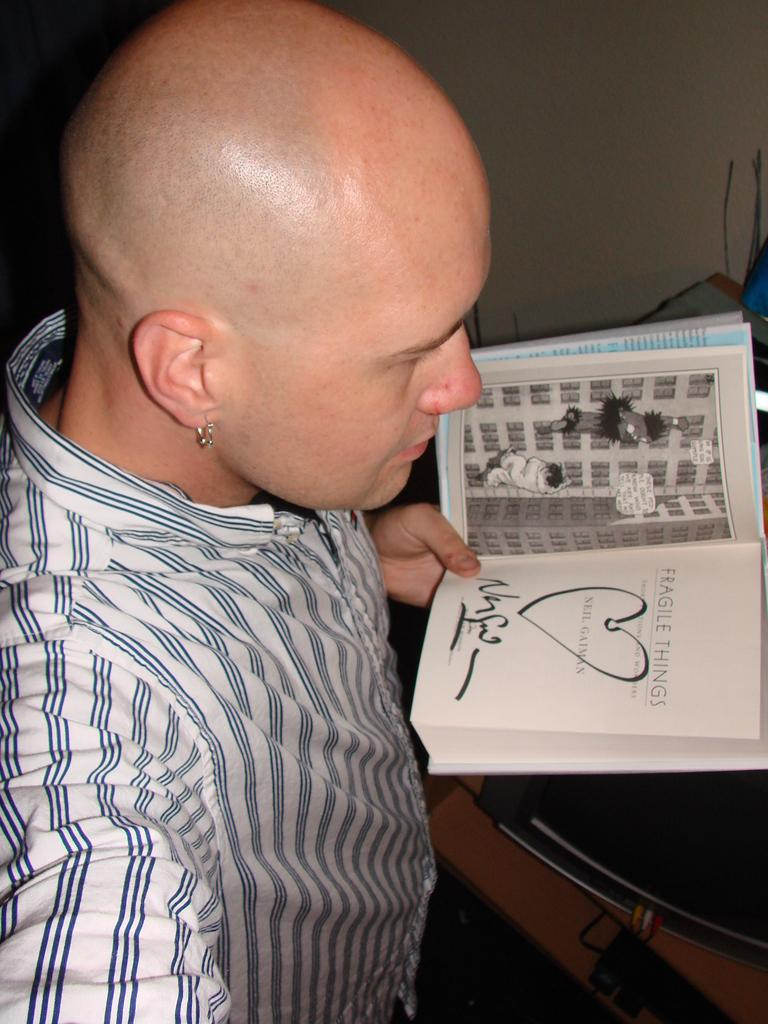What is the person in the image doing? The person is standing in the image and holding a book in their hand. What can be seen on the right side of the image? There is a table on the right side of the image. What is the color of the object on the table? The object on the table is black in color. What type of pet is sitting next to the person in the image? There is no pet present in the image. How many ants can be seen crawling on the book in the image? There are no ants visible in the image. 